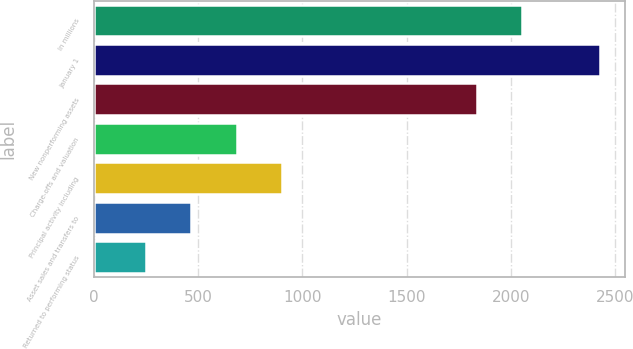<chart> <loc_0><loc_0><loc_500><loc_500><bar_chart><fcel>In millions<fcel>January 1<fcel>New nonperforming assets<fcel>Charge-offs and valuation<fcel>Principal activity including<fcel>Asset sales and transfers to<fcel>Returned to performing status<nl><fcel>2052.6<fcel>2425<fcel>1835<fcel>684.2<fcel>901.8<fcel>466.6<fcel>249<nl></chart> 